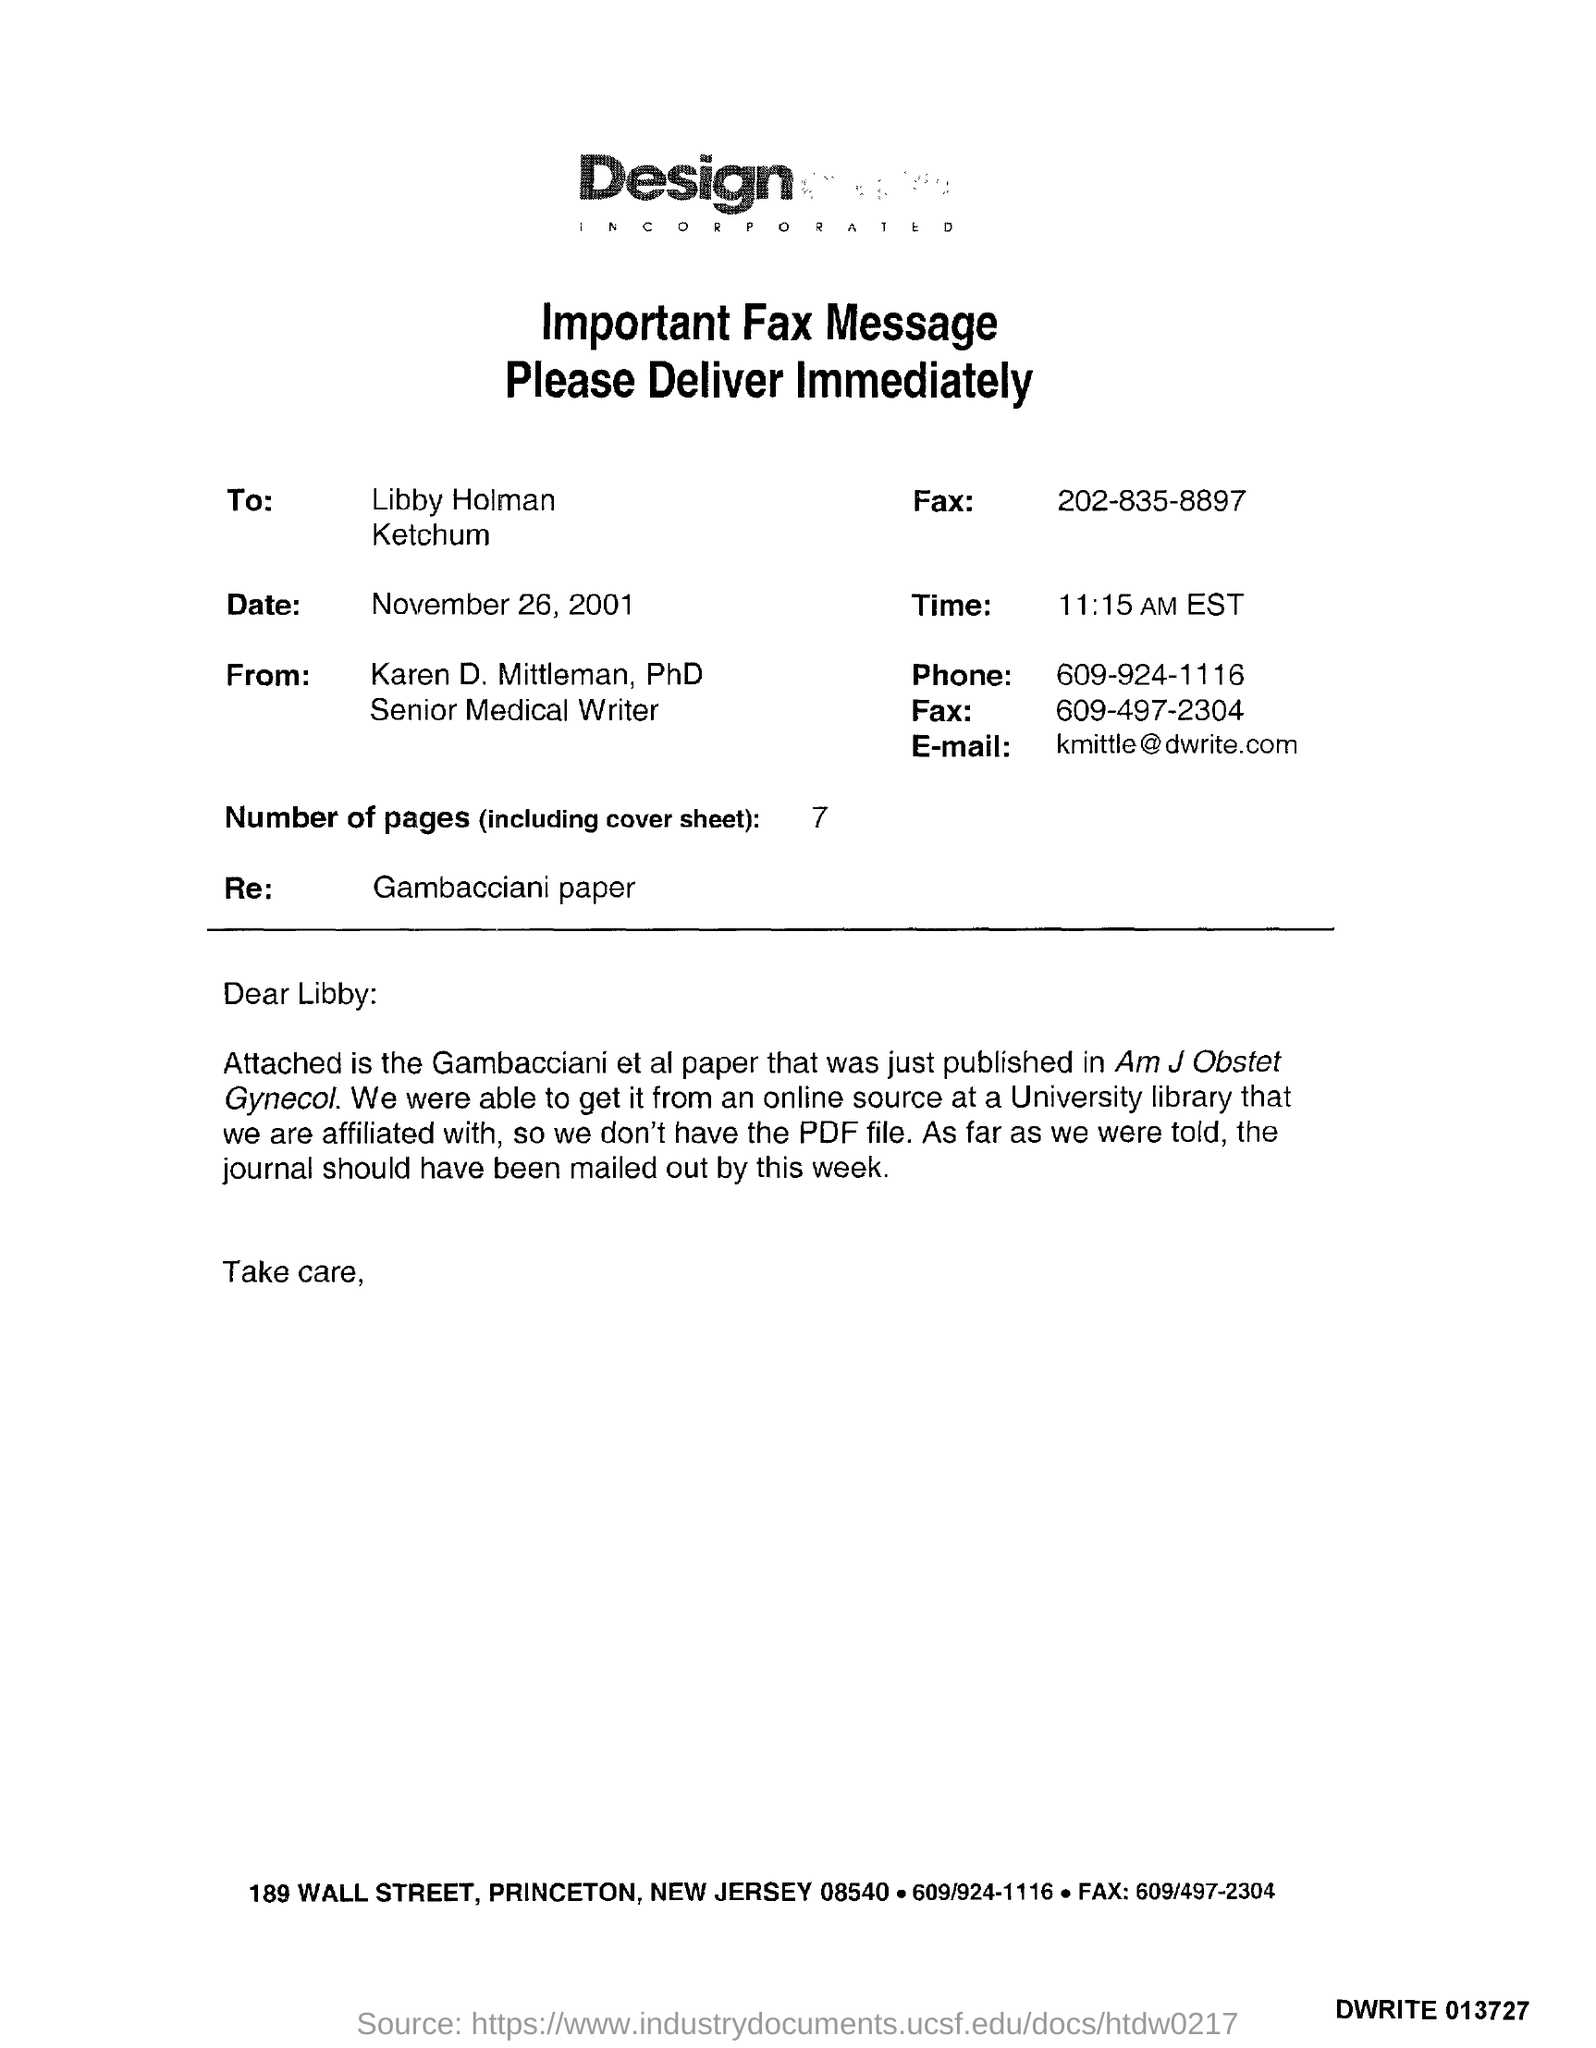What is the date?
Provide a succinct answer. November 26, 2001. What is the time?
Ensure brevity in your answer.  11:15 AM EST. What is the number of pages?
Provide a short and direct response. 7. What is the salutation of this letter?
Your response must be concise. Dear Libby:. What is the E- mail address?
Offer a very short reply. Kmittle@dwrite.com. 